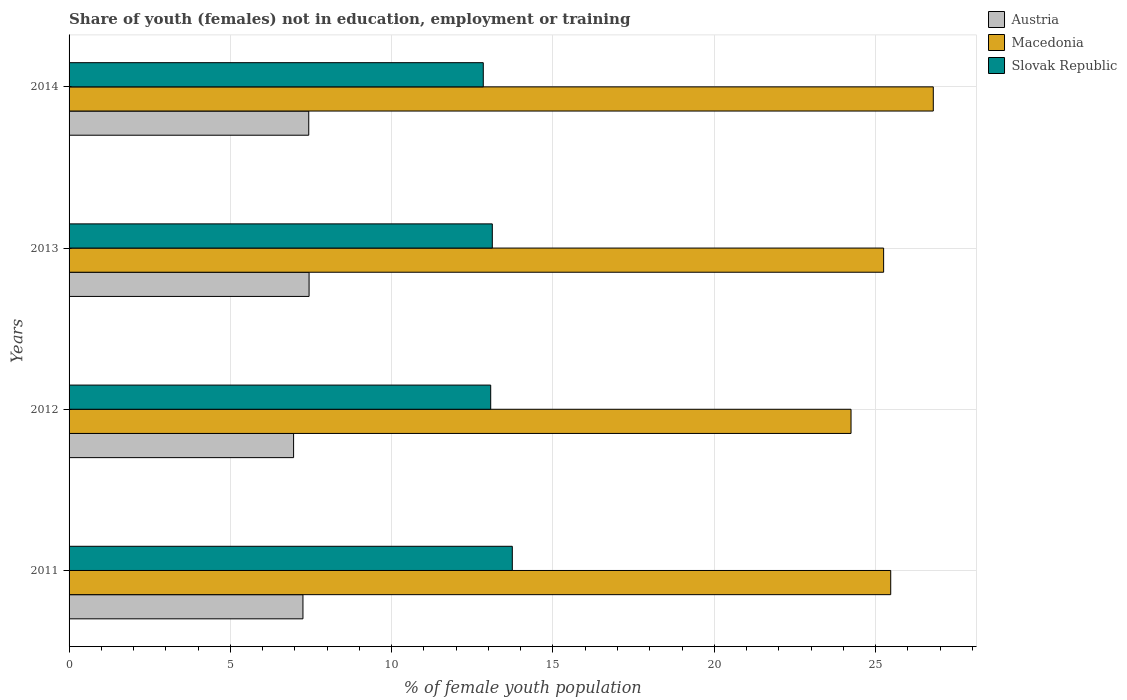How many groups of bars are there?
Offer a terse response. 4. What is the percentage of unemployed female population in in Slovak Republic in 2013?
Your answer should be very brief. 13.12. Across all years, what is the maximum percentage of unemployed female population in in Austria?
Offer a terse response. 7.44. Across all years, what is the minimum percentage of unemployed female population in in Slovak Republic?
Provide a succinct answer. 12.84. In which year was the percentage of unemployed female population in in Slovak Republic maximum?
Your response must be concise. 2011. In which year was the percentage of unemployed female population in in Austria minimum?
Your answer should be compact. 2012. What is the total percentage of unemployed female population in in Austria in the graph?
Provide a short and direct response. 29.08. What is the difference between the percentage of unemployed female population in in Macedonia in 2012 and that in 2014?
Your answer should be very brief. -2.55. What is the difference between the percentage of unemployed female population in in Slovak Republic in 2014 and the percentage of unemployed female population in in Macedonia in 2012?
Your answer should be very brief. -11.4. What is the average percentage of unemployed female population in in Austria per year?
Provide a succinct answer. 7.27. In the year 2013, what is the difference between the percentage of unemployed female population in in Macedonia and percentage of unemployed female population in in Slovak Republic?
Offer a terse response. 12.13. What is the ratio of the percentage of unemployed female population in in Austria in 2011 to that in 2013?
Offer a terse response. 0.97. Is the percentage of unemployed female population in in Austria in 2011 less than that in 2014?
Keep it short and to the point. Yes. Is the difference between the percentage of unemployed female population in in Macedonia in 2013 and 2014 greater than the difference between the percentage of unemployed female population in in Slovak Republic in 2013 and 2014?
Provide a short and direct response. No. What is the difference between the highest and the second highest percentage of unemployed female population in in Austria?
Provide a short and direct response. 0.01. What is the difference between the highest and the lowest percentage of unemployed female population in in Austria?
Offer a terse response. 0.48. In how many years, is the percentage of unemployed female population in in Slovak Republic greater than the average percentage of unemployed female population in in Slovak Republic taken over all years?
Offer a very short reply. 1. Is the sum of the percentage of unemployed female population in in Slovak Republic in 2013 and 2014 greater than the maximum percentage of unemployed female population in in Macedonia across all years?
Your answer should be very brief. No. What does the 2nd bar from the top in 2011 represents?
Make the answer very short. Macedonia. Is it the case that in every year, the sum of the percentage of unemployed female population in in Austria and percentage of unemployed female population in in Macedonia is greater than the percentage of unemployed female population in in Slovak Republic?
Offer a terse response. Yes. Are all the bars in the graph horizontal?
Make the answer very short. Yes. How many years are there in the graph?
Offer a terse response. 4. What is the difference between two consecutive major ticks on the X-axis?
Give a very brief answer. 5. Does the graph contain grids?
Provide a succinct answer. Yes. How many legend labels are there?
Provide a succinct answer. 3. What is the title of the graph?
Your answer should be very brief. Share of youth (females) not in education, employment or training. What is the label or title of the X-axis?
Keep it short and to the point. % of female youth population. What is the % of female youth population of Austria in 2011?
Keep it short and to the point. 7.25. What is the % of female youth population of Macedonia in 2011?
Offer a very short reply. 25.47. What is the % of female youth population of Slovak Republic in 2011?
Keep it short and to the point. 13.74. What is the % of female youth population in Austria in 2012?
Your answer should be compact. 6.96. What is the % of female youth population in Macedonia in 2012?
Provide a short and direct response. 24.24. What is the % of female youth population of Slovak Republic in 2012?
Ensure brevity in your answer.  13.07. What is the % of female youth population of Austria in 2013?
Keep it short and to the point. 7.44. What is the % of female youth population in Macedonia in 2013?
Provide a succinct answer. 25.25. What is the % of female youth population of Slovak Republic in 2013?
Keep it short and to the point. 13.12. What is the % of female youth population of Austria in 2014?
Your answer should be very brief. 7.43. What is the % of female youth population of Macedonia in 2014?
Your answer should be very brief. 26.79. What is the % of female youth population in Slovak Republic in 2014?
Your response must be concise. 12.84. Across all years, what is the maximum % of female youth population in Austria?
Your response must be concise. 7.44. Across all years, what is the maximum % of female youth population in Macedonia?
Your answer should be very brief. 26.79. Across all years, what is the maximum % of female youth population in Slovak Republic?
Offer a very short reply. 13.74. Across all years, what is the minimum % of female youth population in Austria?
Keep it short and to the point. 6.96. Across all years, what is the minimum % of female youth population of Macedonia?
Offer a terse response. 24.24. Across all years, what is the minimum % of female youth population in Slovak Republic?
Provide a short and direct response. 12.84. What is the total % of female youth population in Austria in the graph?
Offer a terse response. 29.08. What is the total % of female youth population of Macedonia in the graph?
Keep it short and to the point. 101.75. What is the total % of female youth population in Slovak Republic in the graph?
Offer a very short reply. 52.77. What is the difference between the % of female youth population of Austria in 2011 and that in 2012?
Keep it short and to the point. 0.29. What is the difference between the % of female youth population in Macedonia in 2011 and that in 2012?
Your response must be concise. 1.23. What is the difference between the % of female youth population in Slovak Republic in 2011 and that in 2012?
Provide a short and direct response. 0.67. What is the difference between the % of female youth population of Austria in 2011 and that in 2013?
Ensure brevity in your answer.  -0.19. What is the difference between the % of female youth population in Macedonia in 2011 and that in 2013?
Keep it short and to the point. 0.22. What is the difference between the % of female youth population of Slovak Republic in 2011 and that in 2013?
Your answer should be compact. 0.62. What is the difference between the % of female youth population in Austria in 2011 and that in 2014?
Offer a very short reply. -0.18. What is the difference between the % of female youth population in Macedonia in 2011 and that in 2014?
Your response must be concise. -1.32. What is the difference between the % of female youth population of Austria in 2012 and that in 2013?
Offer a terse response. -0.48. What is the difference between the % of female youth population in Macedonia in 2012 and that in 2013?
Offer a very short reply. -1.01. What is the difference between the % of female youth population of Austria in 2012 and that in 2014?
Your response must be concise. -0.47. What is the difference between the % of female youth population of Macedonia in 2012 and that in 2014?
Ensure brevity in your answer.  -2.55. What is the difference between the % of female youth population in Slovak Republic in 2012 and that in 2014?
Your answer should be compact. 0.23. What is the difference between the % of female youth population of Austria in 2013 and that in 2014?
Your response must be concise. 0.01. What is the difference between the % of female youth population of Macedonia in 2013 and that in 2014?
Make the answer very short. -1.54. What is the difference between the % of female youth population in Slovak Republic in 2013 and that in 2014?
Offer a terse response. 0.28. What is the difference between the % of female youth population in Austria in 2011 and the % of female youth population in Macedonia in 2012?
Provide a short and direct response. -16.99. What is the difference between the % of female youth population of Austria in 2011 and the % of female youth population of Slovak Republic in 2012?
Provide a succinct answer. -5.82. What is the difference between the % of female youth population of Macedonia in 2011 and the % of female youth population of Slovak Republic in 2012?
Your answer should be very brief. 12.4. What is the difference between the % of female youth population in Austria in 2011 and the % of female youth population in Macedonia in 2013?
Your response must be concise. -18. What is the difference between the % of female youth population of Austria in 2011 and the % of female youth population of Slovak Republic in 2013?
Keep it short and to the point. -5.87. What is the difference between the % of female youth population in Macedonia in 2011 and the % of female youth population in Slovak Republic in 2013?
Your response must be concise. 12.35. What is the difference between the % of female youth population in Austria in 2011 and the % of female youth population in Macedonia in 2014?
Provide a short and direct response. -19.54. What is the difference between the % of female youth population of Austria in 2011 and the % of female youth population of Slovak Republic in 2014?
Provide a short and direct response. -5.59. What is the difference between the % of female youth population of Macedonia in 2011 and the % of female youth population of Slovak Republic in 2014?
Make the answer very short. 12.63. What is the difference between the % of female youth population in Austria in 2012 and the % of female youth population in Macedonia in 2013?
Offer a very short reply. -18.29. What is the difference between the % of female youth population in Austria in 2012 and the % of female youth population in Slovak Republic in 2013?
Your answer should be compact. -6.16. What is the difference between the % of female youth population in Macedonia in 2012 and the % of female youth population in Slovak Republic in 2013?
Provide a short and direct response. 11.12. What is the difference between the % of female youth population in Austria in 2012 and the % of female youth population in Macedonia in 2014?
Your answer should be very brief. -19.83. What is the difference between the % of female youth population of Austria in 2012 and the % of female youth population of Slovak Republic in 2014?
Offer a very short reply. -5.88. What is the difference between the % of female youth population of Austria in 2013 and the % of female youth population of Macedonia in 2014?
Keep it short and to the point. -19.35. What is the difference between the % of female youth population in Macedonia in 2013 and the % of female youth population in Slovak Republic in 2014?
Ensure brevity in your answer.  12.41. What is the average % of female youth population in Austria per year?
Your answer should be very brief. 7.27. What is the average % of female youth population of Macedonia per year?
Make the answer very short. 25.44. What is the average % of female youth population of Slovak Republic per year?
Offer a very short reply. 13.19. In the year 2011, what is the difference between the % of female youth population of Austria and % of female youth population of Macedonia?
Offer a very short reply. -18.22. In the year 2011, what is the difference between the % of female youth population of Austria and % of female youth population of Slovak Republic?
Your answer should be very brief. -6.49. In the year 2011, what is the difference between the % of female youth population in Macedonia and % of female youth population in Slovak Republic?
Your response must be concise. 11.73. In the year 2012, what is the difference between the % of female youth population of Austria and % of female youth population of Macedonia?
Your answer should be very brief. -17.28. In the year 2012, what is the difference between the % of female youth population of Austria and % of female youth population of Slovak Republic?
Give a very brief answer. -6.11. In the year 2012, what is the difference between the % of female youth population of Macedonia and % of female youth population of Slovak Republic?
Your answer should be very brief. 11.17. In the year 2013, what is the difference between the % of female youth population in Austria and % of female youth population in Macedonia?
Give a very brief answer. -17.81. In the year 2013, what is the difference between the % of female youth population of Austria and % of female youth population of Slovak Republic?
Provide a short and direct response. -5.68. In the year 2013, what is the difference between the % of female youth population in Macedonia and % of female youth population in Slovak Republic?
Make the answer very short. 12.13. In the year 2014, what is the difference between the % of female youth population of Austria and % of female youth population of Macedonia?
Make the answer very short. -19.36. In the year 2014, what is the difference between the % of female youth population in Austria and % of female youth population in Slovak Republic?
Make the answer very short. -5.41. In the year 2014, what is the difference between the % of female youth population in Macedonia and % of female youth population in Slovak Republic?
Keep it short and to the point. 13.95. What is the ratio of the % of female youth population of Austria in 2011 to that in 2012?
Provide a short and direct response. 1.04. What is the ratio of the % of female youth population in Macedonia in 2011 to that in 2012?
Offer a terse response. 1.05. What is the ratio of the % of female youth population of Slovak Republic in 2011 to that in 2012?
Your answer should be very brief. 1.05. What is the ratio of the % of female youth population of Austria in 2011 to that in 2013?
Your answer should be compact. 0.97. What is the ratio of the % of female youth population in Macedonia in 2011 to that in 2013?
Offer a very short reply. 1.01. What is the ratio of the % of female youth population of Slovak Republic in 2011 to that in 2013?
Provide a short and direct response. 1.05. What is the ratio of the % of female youth population of Austria in 2011 to that in 2014?
Offer a very short reply. 0.98. What is the ratio of the % of female youth population in Macedonia in 2011 to that in 2014?
Ensure brevity in your answer.  0.95. What is the ratio of the % of female youth population in Slovak Republic in 2011 to that in 2014?
Ensure brevity in your answer.  1.07. What is the ratio of the % of female youth population in Austria in 2012 to that in 2013?
Give a very brief answer. 0.94. What is the ratio of the % of female youth population in Macedonia in 2012 to that in 2013?
Your answer should be compact. 0.96. What is the ratio of the % of female youth population of Slovak Republic in 2012 to that in 2013?
Provide a short and direct response. 1. What is the ratio of the % of female youth population of Austria in 2012 to that in 2014?
Ensure brevity in your answer.  0.94. What is the ratio of the % of female youth population of Macedonia in 2012 to that in 2014?
Ensure brevity in your answer.  0.9. What is the ratio of the % of female youth population in Slovak Republic in 2012 to that in 2014?
Your answer should be very brief. 1.02. What is the ratio of the % of female youth population in Macedonia in 2013 to that in 2014?
Provide a short and direct response. 0.94. What is the ratio of the % of female youth population of Slovak Republic in 2013 to that in 2014?
Keep it short and to the point. 1.02. What is the difference between the highest and the second highest % of female youth population of Macedonia?
Your answer should be compact. 1.32. What is the difference between the highest and the second highest % of female youth population in Slovak Republic?
Make the answer very short. 0.62. What is the difference between the highest and the lowest % of female youth population in Austria?
Ensure brevity in your answer.  0.48. What is the difference between the highest and the lowest % of female youth population of Macedonia?
Your answer should be compact. 2.55. What is the difference between the highest and the lowest % of female youth population of Slovak Republic?
Provide a succinct answer. 0.9. 